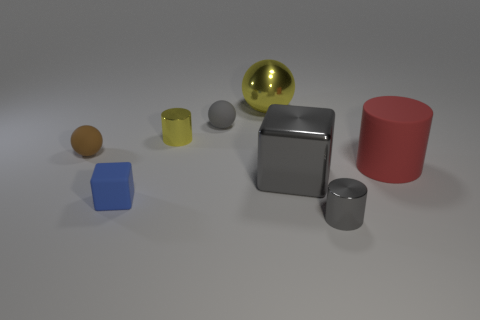How many other red objects have the same shape as the large matte thing?
Make the answer very short. 0. Is the shape of the big gray shiny thing the same as the tiny yellow object?
Make the answer very short. No. How many things are either cubes that are on the right side of the yellow metal cylinder or blue rubber things?
Give a very brief answer. 2. What shape is the yellow metallic thing on the right side of the tiny matte sphere to the right of the small metal cylinder behind the large matte object?
Offer a very short reply. Sphere. What shape is the brown object that is made of the same material as the small blue object?
Your answer should be compact. Sphere. What size is the brown sphere?
Make the answer very short. Small. Do the brown sphere and the matte block have the same size?
Offer a very short reply. Yes. How many objects are either shiny cylinders in front of the small yellow cylinder or metallic things that are to the right of the shiny block?
Make the answer very short. 1. How many big things are in front of the yellow metallic thing behind the small cylinder left of the tiny gray shiny object?
Give a very brief answer. 2. What is the size of the blue matte thing that is right of the tiny brown thing?
Ensure brevity in your answer.  Small. 